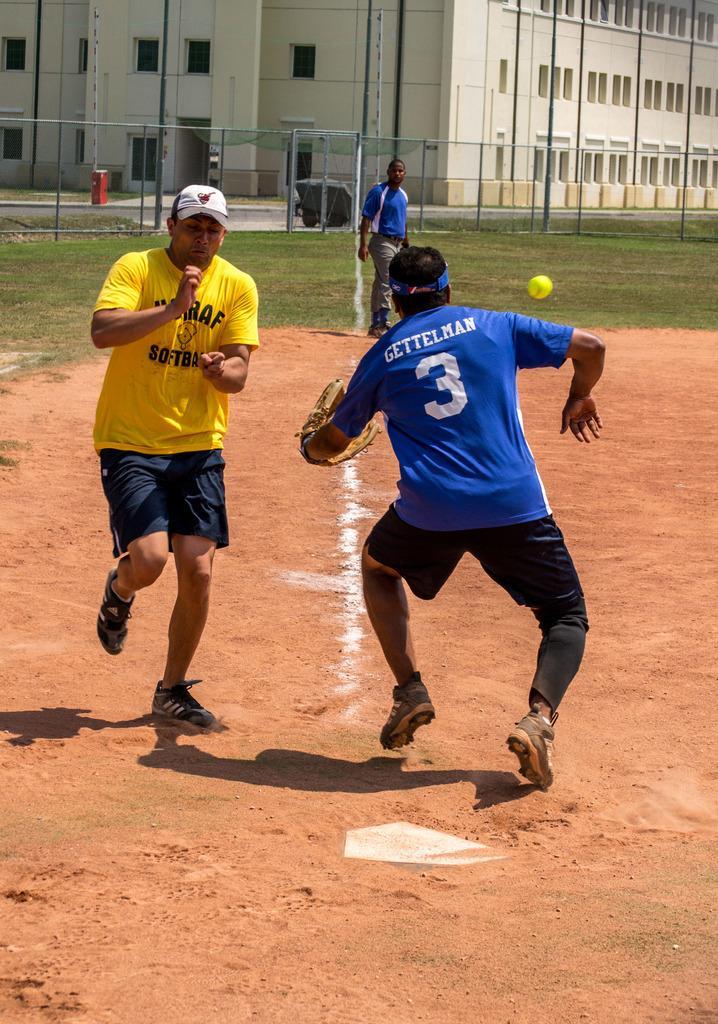How would you summarize this image in a sentence or two? On the left side a man is running. He wore a yellow color t-shirt, on the right side this person is running, he wore blue color t-shirt. This is the building. 